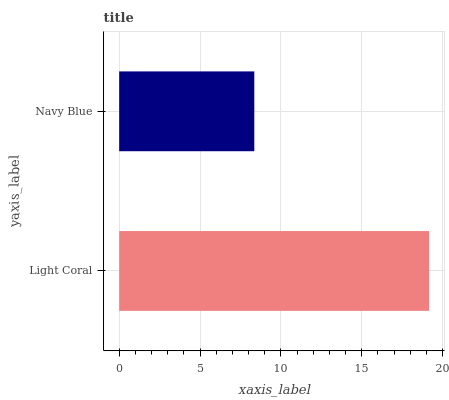Is Navy Blue the minimum?
Answer yes or no. Yes. Is Light Coral the maximum?
Answer yes or no. Yes. Is Navy Blue the maximum?
Answer yes or no. No. Is Light Coral greater than Navy Blue?
Answer yes or no. Yes. Is Navy Blue less than Light Coral?
Answer yes or no. Yes. Is Navy Blue greater than Light Coral?
Answer yes or no. No. Is Light Coral less than Navy Blue?
Answer yes or no. No. Is Light Coral the high median?
Answer yes or no. Yes. Is Navy Blue the low median?
Answer yes or no. Yes. Is Navy Blue the high median?
Answer yes or no. No. Is Light Coral the low median?
Answer yes or no. No. 